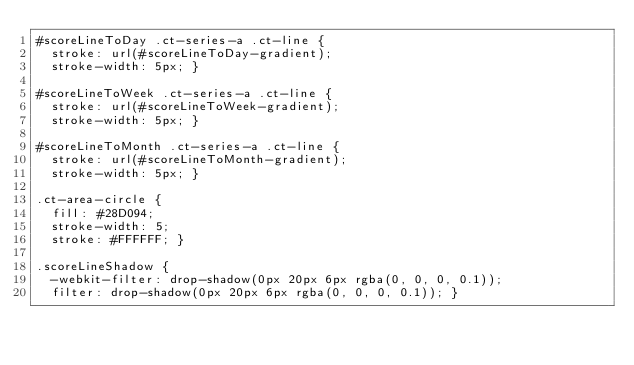Convert code to text. <code><loc_0><loc_0><loc_500><loc_500><_CSS_>#scoreLineToDay .ct-series-a .ct-line {
  stroke: url(#scoreLineToDay-gradient);
  stroke-width: 5px; }

#scoreLineToWeek .ct-series-a .ct-line {
  stroke: url(#scoreLineToWeek-gradient);
  stroke-width: 5px; }

#scoreLineToMonth .ct-series-a .ct-line {
  stroke: url(#scoreLineToMonth-gradient);
  stroke-width: 5px; }

.ct-area-circle {
  fill: #28D094;
  stroke-width: 5;
  stroke: #FFFFFF; }

.scoreLineShadow {
  -webkit-filter: drop-shadow(0px 20px 6px rgba(0, 0, 0, 0.1));
  filter: drop-shadow(0px 20px 6px rgba(0, 0, 0, 0.1)); }
</code> 